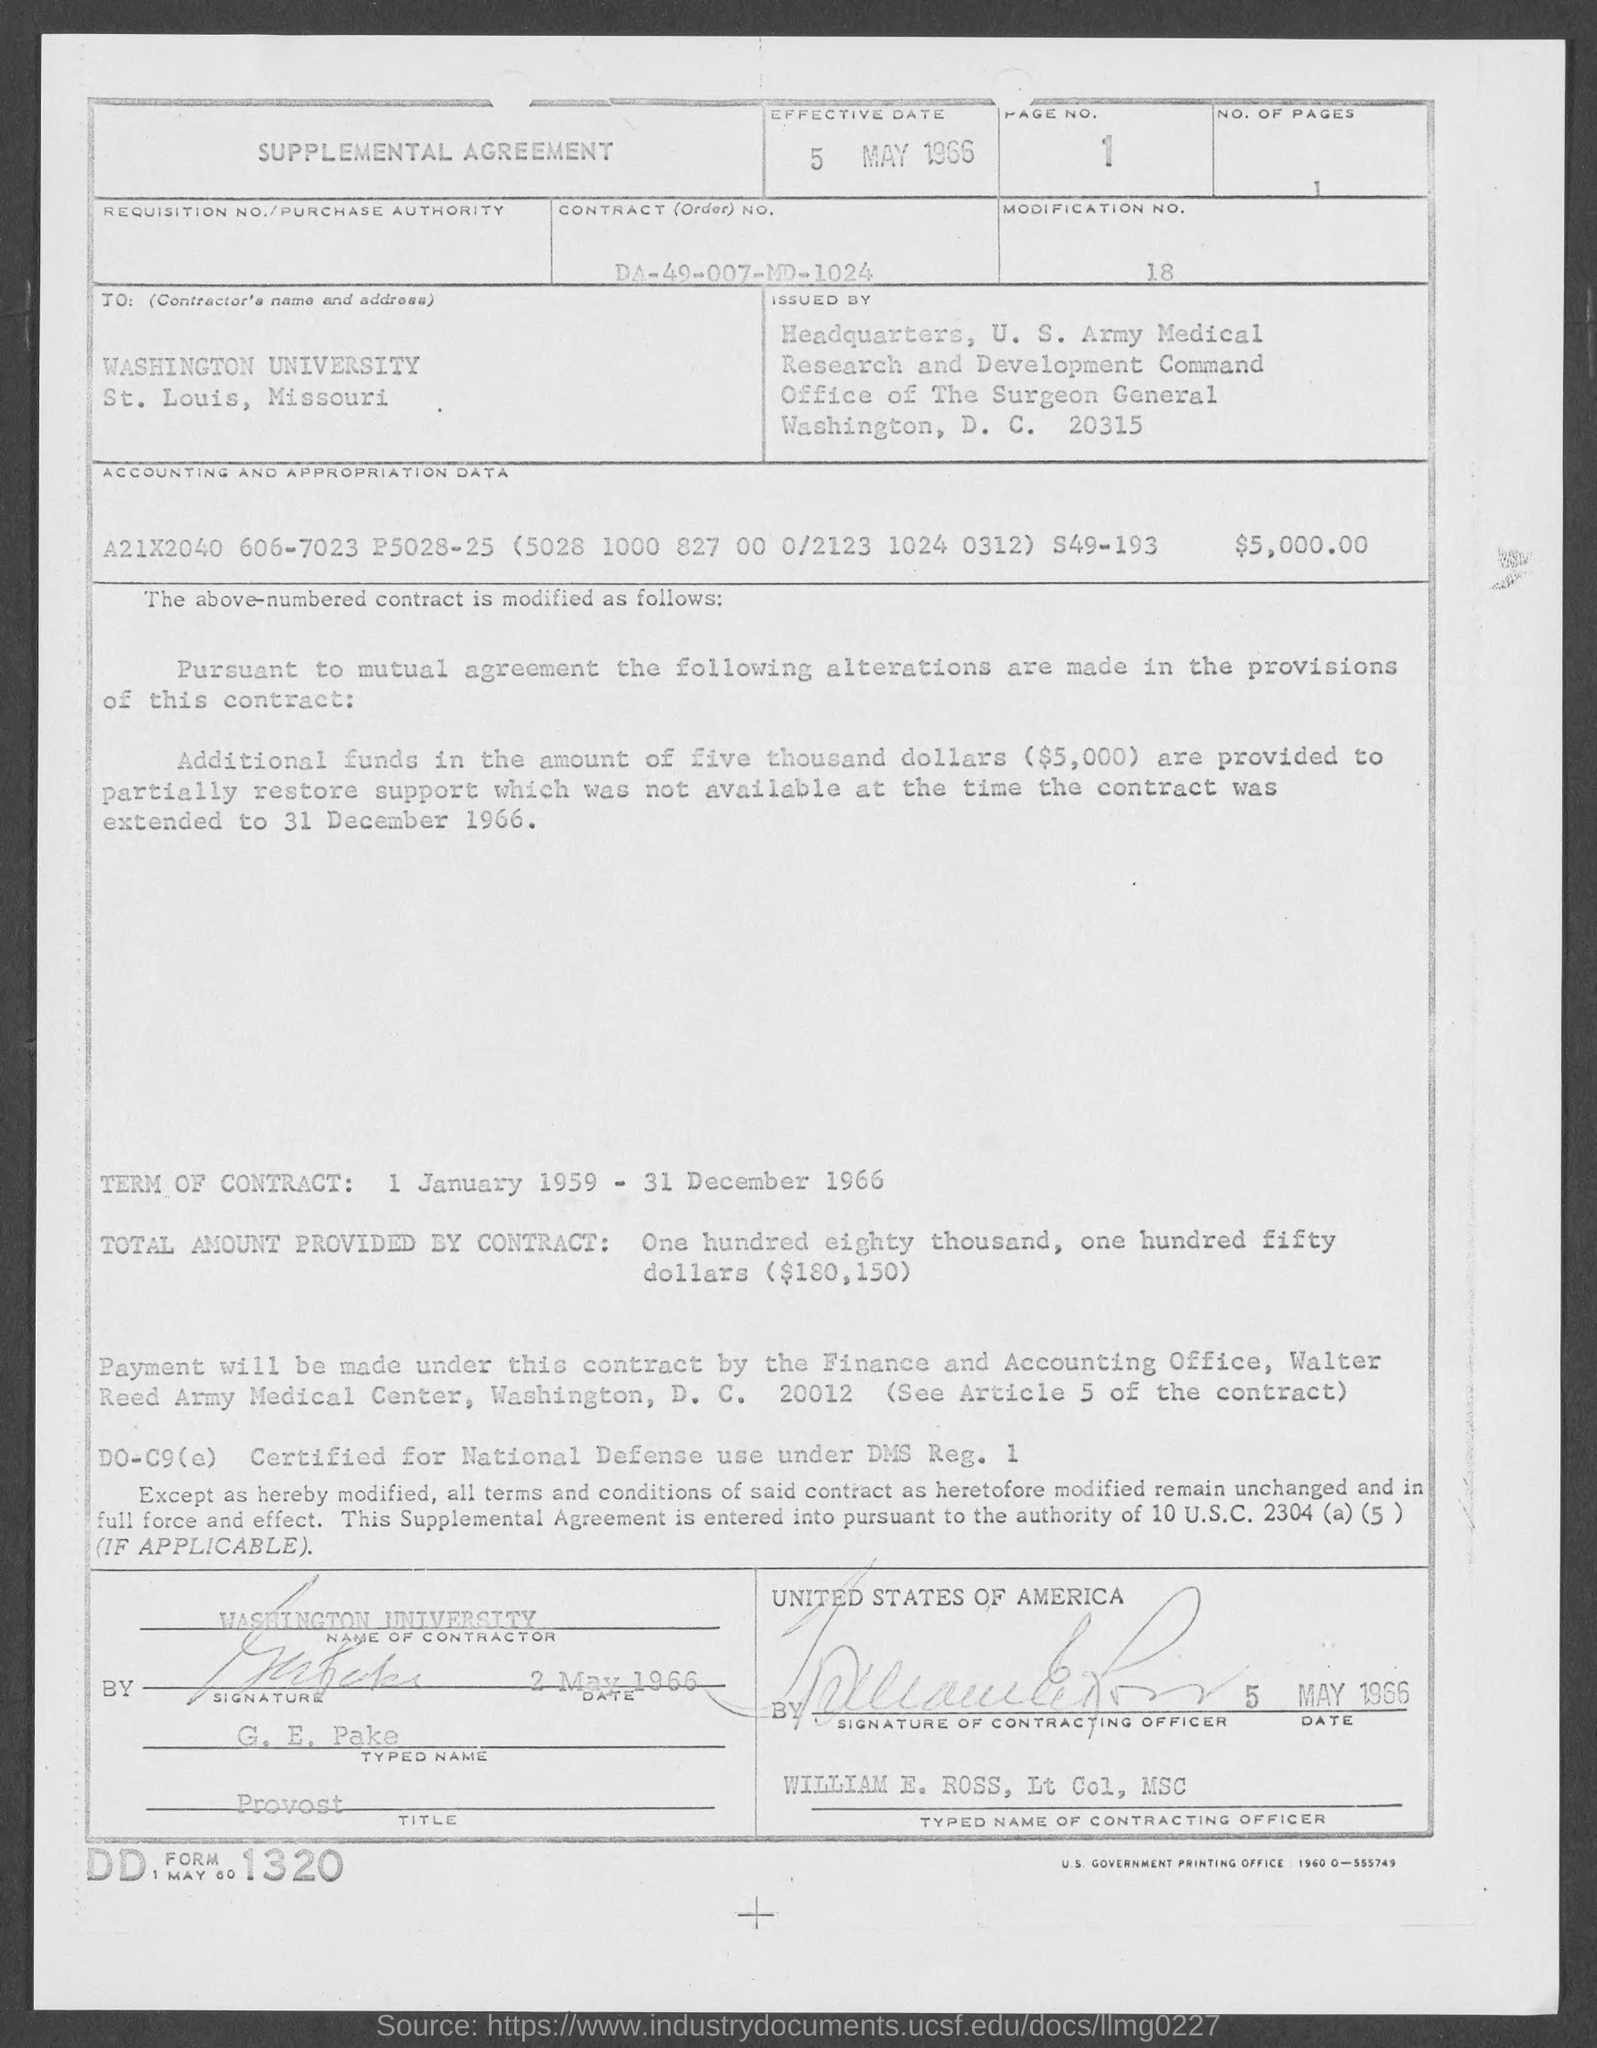Highlight a few significant elements in this photo. What is the typed name? It is George E. Pake. The contractor name is Washington University. The document is known as the "Supplemental Agreement. The effective date of May 5th, 1966, has been declared. The typed name of the contracting officer is William E. Ross. 